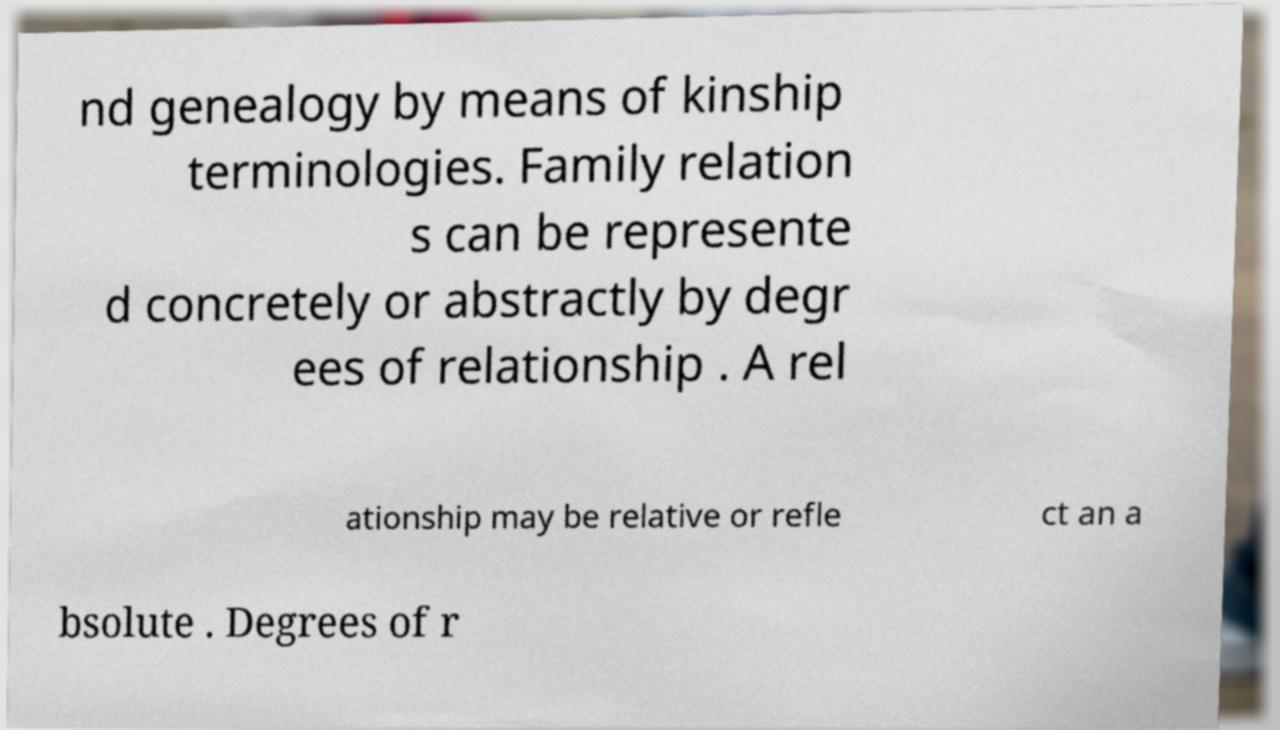For documentation purposes, I need the text within this image transcribed. Could you provide that? nd genealogy by means of kinship terminologies. Family relation s can be represente d concretely or abstractly by degr ees of relationship . A rel ationship may be relative or refle ct an a bsolute . Degrees of r 